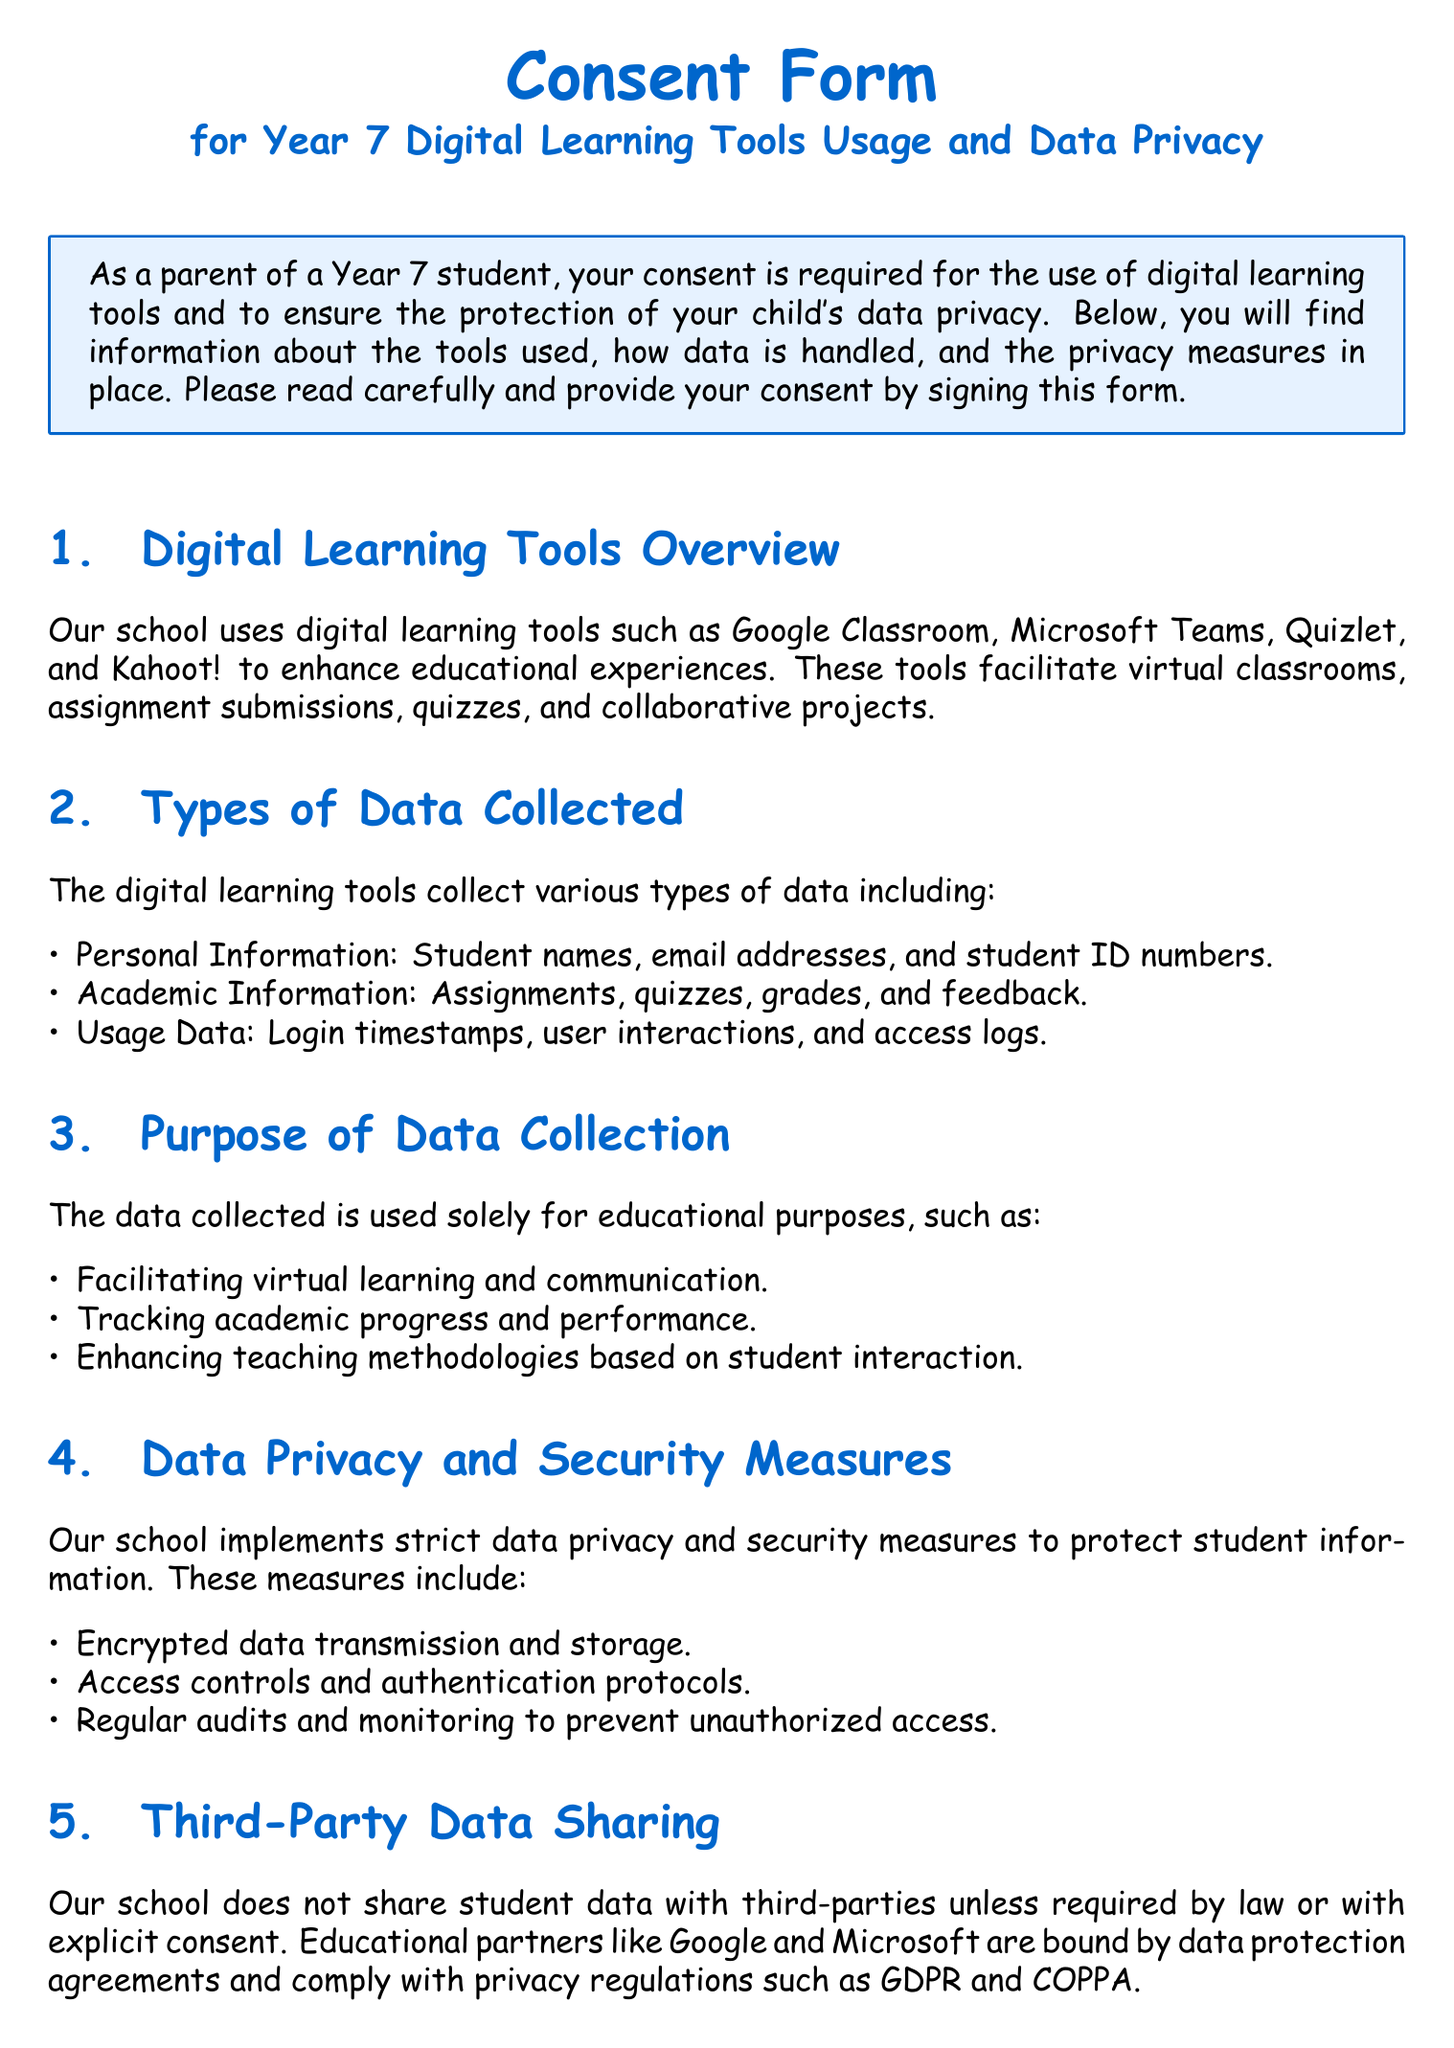What are the digital learning tools used in Year 7? The section titled "Digital Learning Tools Overview" lists tools such as Google Classroom, Microsoft Teams, Quizlet, and Kahoot!.
Answer: Google Classroom, Microsoft Teams, Quizlet, Kahoot! What types of personal information are collected? The "Types of Data Collected" section specifies types of personal information collected, including names, email addresses, and student ID numbers.
Answer: Names, email addresses, student ID numbers What is the main purpose of data collection? The "Purpose of Data Collection" section highlights that data is collected for educational purposes, including tracking academic progress.
Answer: Educational purposes Which security measure is implemented to protect student information? The "Data Privacy and Security Measures" section lists encrypted data transmission and storage as a security measure protecting student information.
Answer: Encrypted data transmission What rights do parents have regarding their child's data? The "Parental Rights" section outlines rights such as accessing and reviewing data, requesting corrections, and withdrawing consent.
Answer: Access and review data What does the consent form require from parents? The "Consent Declaration" section states that parents must sign to acknowledge understanding of the information provided.
Answer: Acknowledgment and signature Is student data shared with third parties? The "Third-Party Data Sharing" section states that student data is not shared with third parties unless required by law or with consent.
Answer: No What kind of educational partners does the school engage with? The section on "Third-Party Data Sharing" mentions educational partners such as Google and Microsoft.
Answer: Google and Microsoft How is data protected against unauthorized access? The "Data Privacy and Security Measures" section mentions regular audits and monitoring as a method to prevent unauthorized access.
Answer: Regular audits and monitoring 